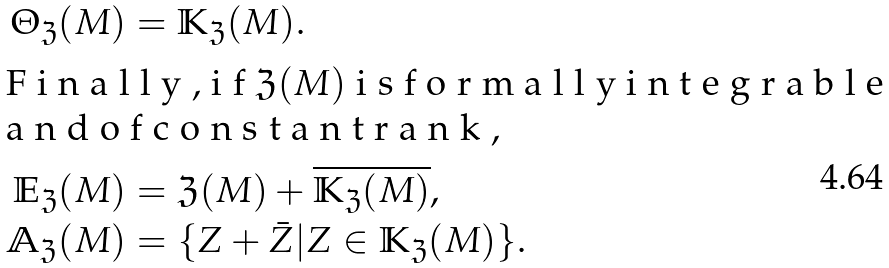Convert formula to latex. <formula><loc_0><loc_0><loc_500><loc_500>\Theta _ { \mathfrak { Z } } ( M ) & = \mathbb { K } _ { \mathfrak { Z } } ( M ) . \\ \intertext { F i n a l l y , i f $ \mathfrak { Z } ( M ) $ i s f o r m a l l y i n t e g r a b l e a n d o f c o n s t a n t r a n k , } \mathbb { E } _ { \mathfrak { Z } } ( M ) & = \mathfrak { Z } ( M ) + \overline { \mathbb { K } _ { \mathfrak { Z } } ( M ) } , \\ \mathbb { A } _ { \mathfrak { Z } } ( M ) & = \{ Z + \bar { Z } | Z \in \mathbb { K } _ { \mathfrak { Z } } ( M ) \} .</formula> 